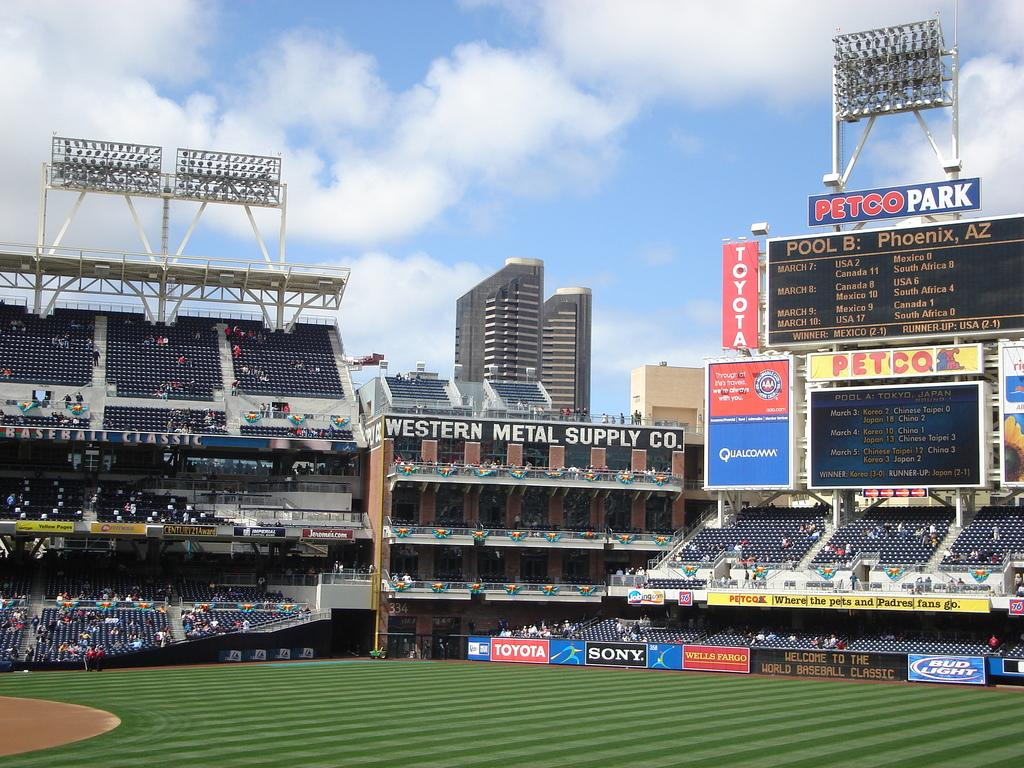<image>
Create a compact narrative representing the image presented. The Petco Park showing Pool B: Phoenix, AZ and Pool A: Tokyo, Japan 